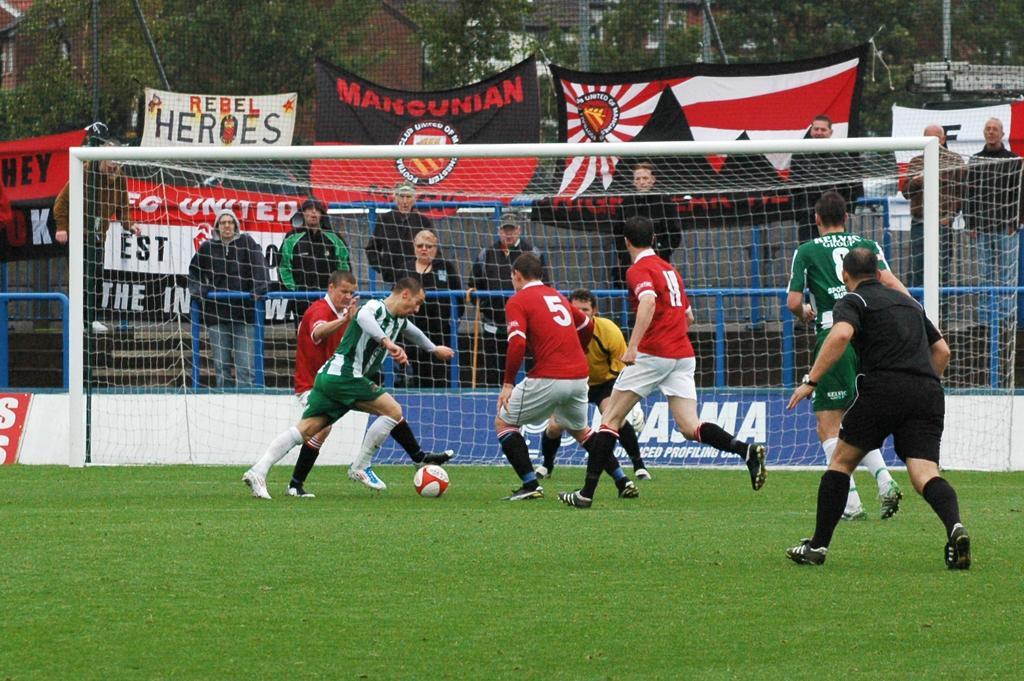Please provide a concise description of this image. As we can see in the image there is a fence, flag and few people playing with football. 